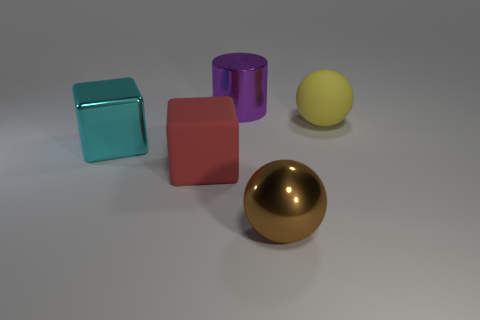How many yellow spheres are the same size as the cylinder?
Offer a very short reply. 1. What is the shape of the big rubber object on the left side of the large purple cylinder?
Give a very brief answer. Cube. Is the number of cyan shiny objects less than the number of small yellow matte things?
Ensure brevity in your answer.  No. Is there any other thing of the same color as the metallic sphere?
Ensure brevity in your answer.  No. There is a rubber object on the left side of the large purple cylinder; what is its size?
Provide a short and direct response. Large. Are there more big yellow matte balls than matte things?
Offer a terse response. No. What is the material of the cylinder?
Give a very brief answer. Metal. What number of other things are made of the same material as the yellow ball?
Your answer should be compact. 1. What number of small yellow shiny cubes are there?
Your response must be concise. 0. There is another large thing that is the same shape as the big red matte thing; what is its material?
Keep it short and to the point. Metal. 